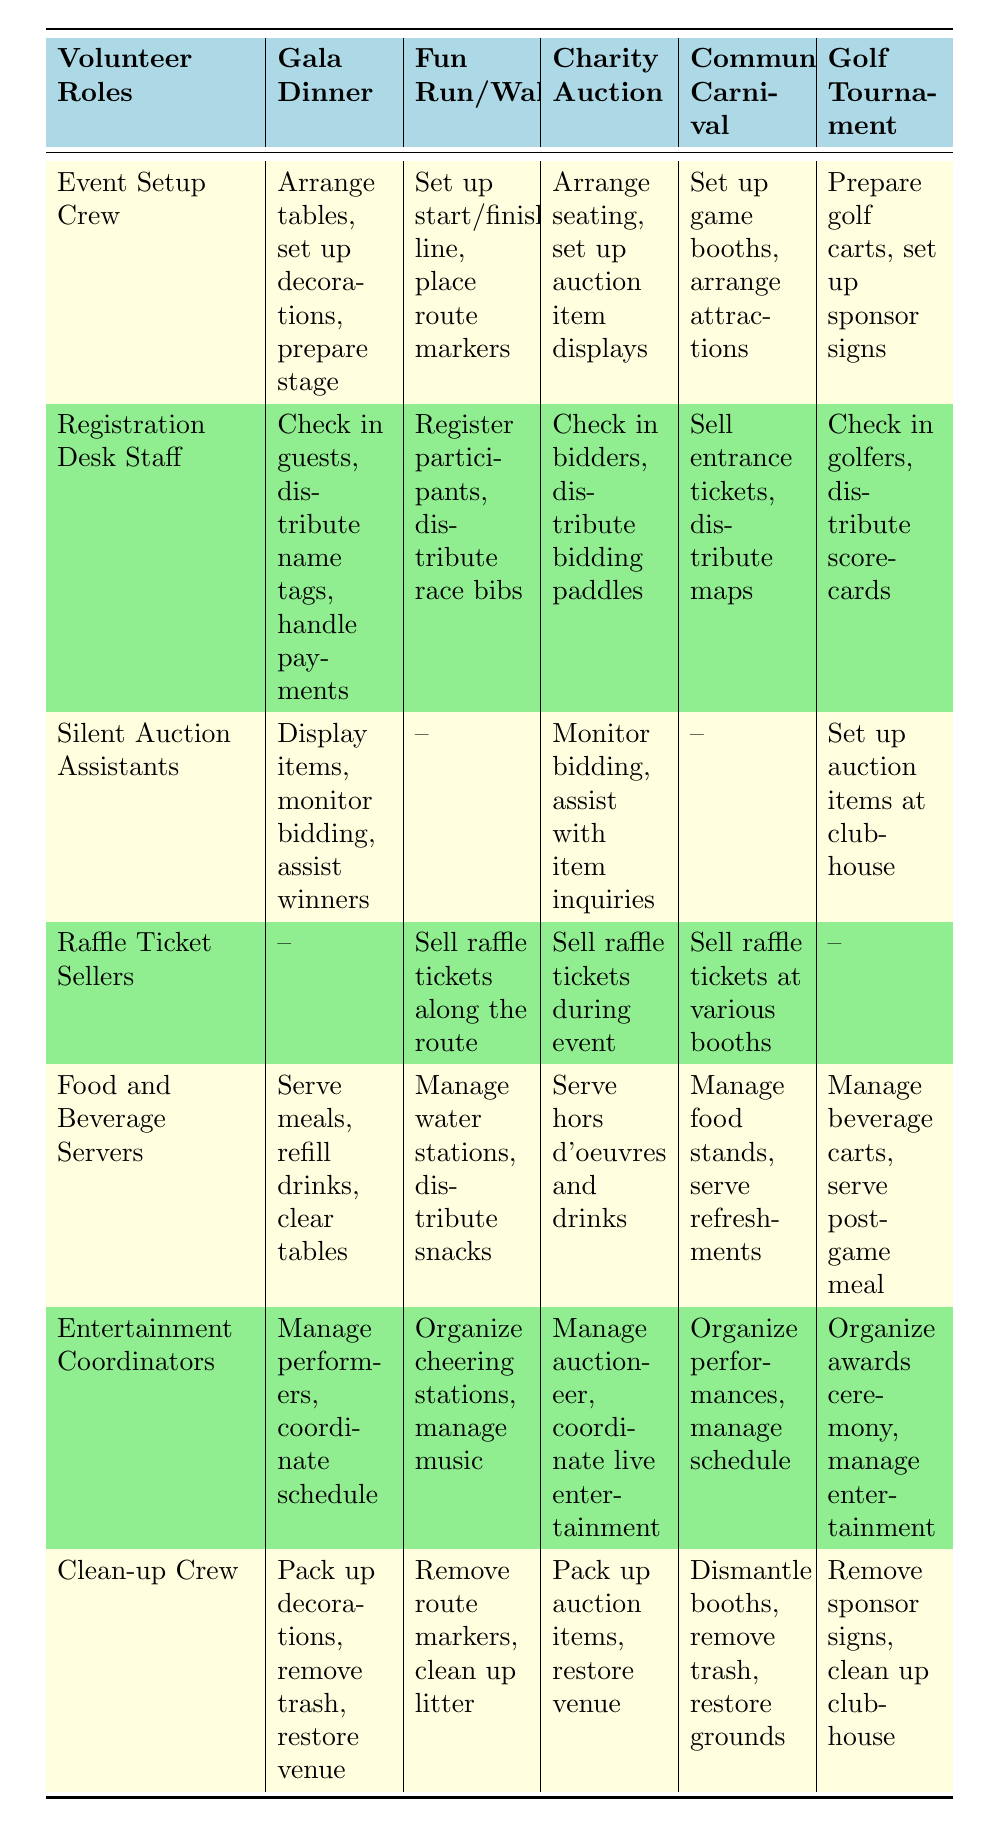What are the responsibilities of the Food and Beverage Servers at the Gala Dinner? The responsibilities for the Food and Beverage Servers at the Gala Dinner, according to the table, are to serve meals, refill drinks, and clear tables.
Answer: Serve meals, refill drinks, clear tables Which roles are involved in both the Charity Auction and Community Carnival? By comparing the two fundraiser formats side by side, the roles that are involved in both the Charity Auction and Community Carnival are the Raffle Ticket Sellers and the Food and Beverage Servers.
Answer: Raffle Ticket Sellers, Food and Beverage Servers Do Entertainment Coordinators have responsibilities in the Fun Run/Walk? According to the table, the Entertainment Coordinators are involved in the Fun Run/Walk with responsibilities to organize cheering stations and manage music. Therefore, the answer is yes.
Answer: Yes How many distinct responsibilities does the Clean-up Crew have across all formats? By analyzing the Clean-up Crew's responsibilities listed for each fundraiser format, they have a total of 5 distinct responsibilities: 1) Pack up decorations, 2) Remove trash, 3) Restore venue, 4) Dismantle booths, 5) Clean up clubhouse. Thus, the answer is 5.
Answer: 5 Is it true that Raffle Ticket Sellers only have responsibilities in Charity Auction and Community Carnival? Checking the table, we find that Raffle Ticket Sellers are listed under the Community Carnival but are also assigned to the Fun Run/Walk and the Charity Auction, indicating that the statement is false.
Answer: No Which fundraiser format requires the Event Setup Crew to prepare golf carts? Looking at the responsibilities of the Event Setup Crew for each format, only the Golf Tournament includes the task of preparing golf carts, as shown in that column.
Answer: Golf Tournament List all the roles that involve managing or coordinating entertainment. The roles that involve managing or coordinating entertainment across the formats include Entertainment Coordinators and Silent Auction Assistants. The Entertainment Coordinators appear in every format except for the Fun Run/Walk where there's no mention, while the Silent Auction Assistants are involved in the Gala Dinner, Charity Auction, and Golf Tournament.
Answer: Entertainment Coordinators, Silent Auction Assistants Which fundraiser format involves the responsibility of selling raffle tickets at various booths? Reviewing the Community Carnival responsibilities, it specifically mentions that Raffle Ticket Sellers sell raffle tickets at various booths during the event.
Answer: Community Carnival 